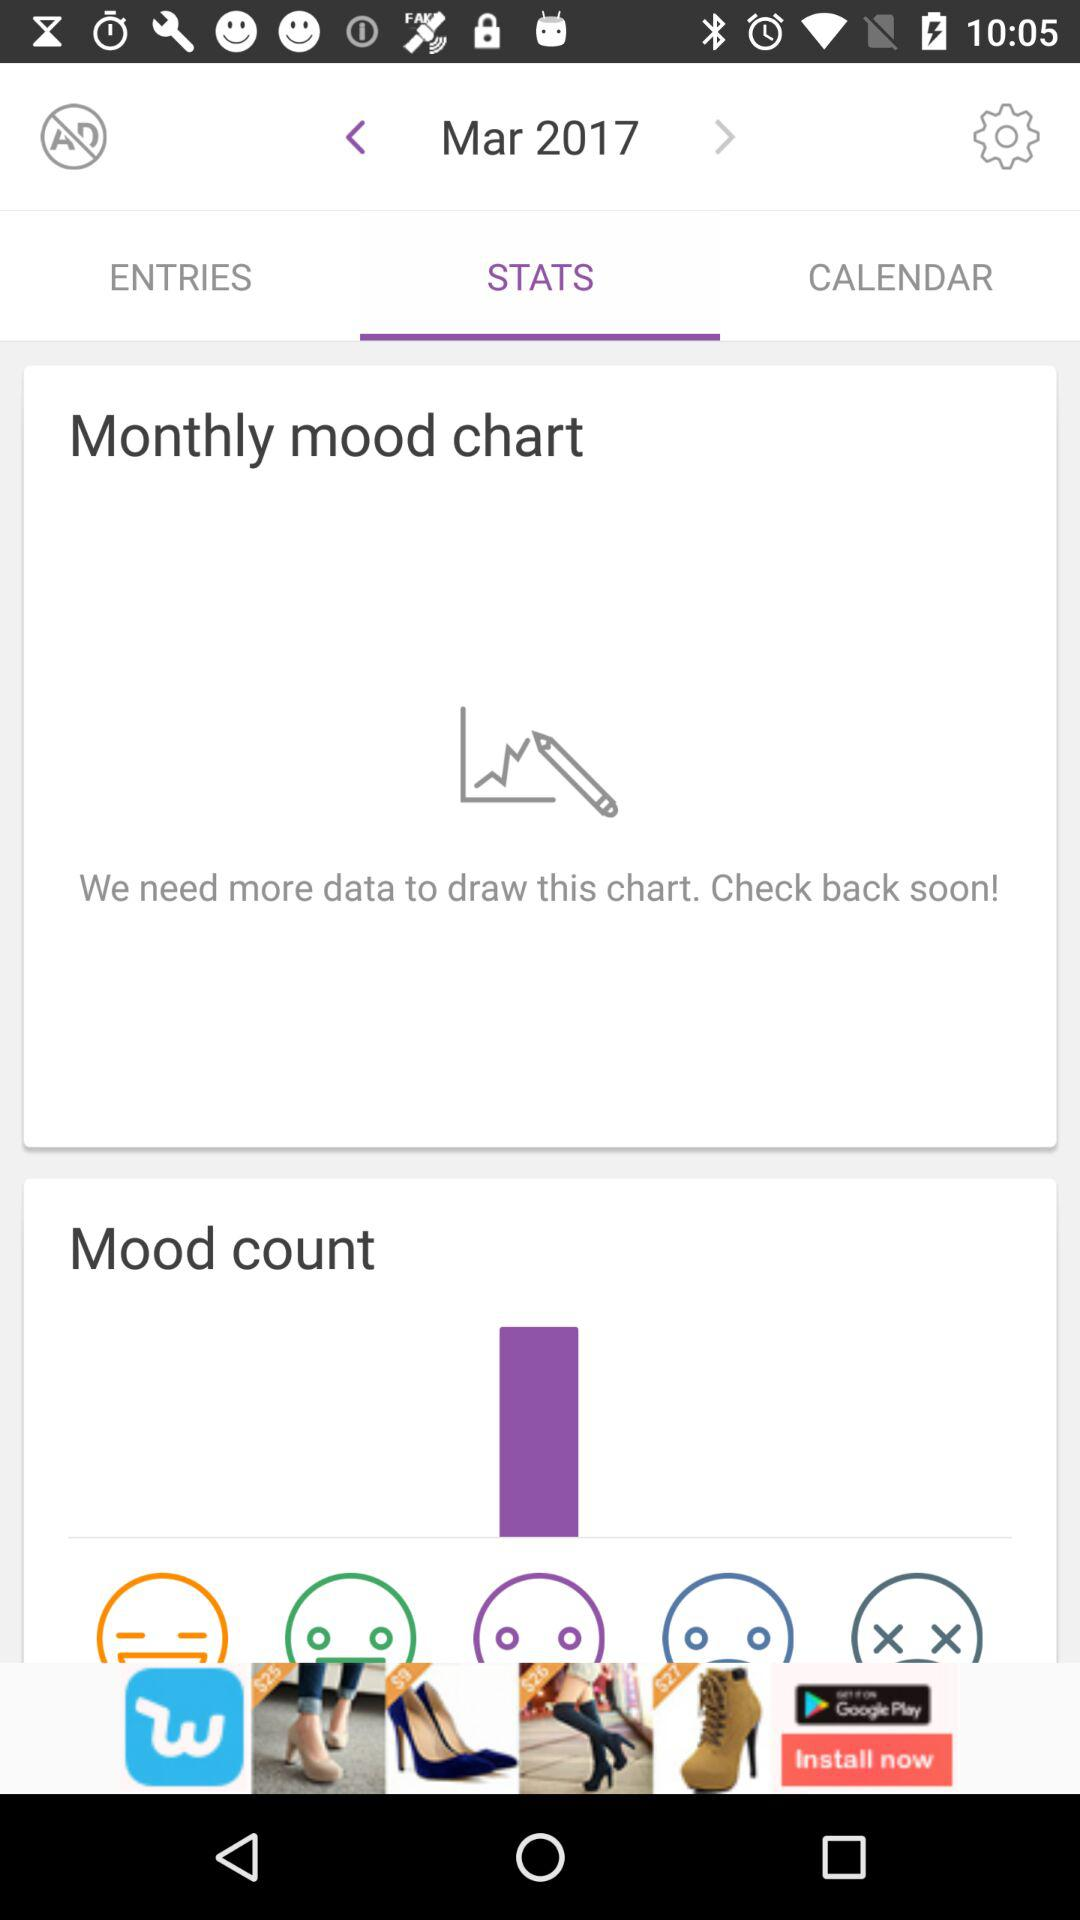Which tab is selected? The selected tab is "STATS". 